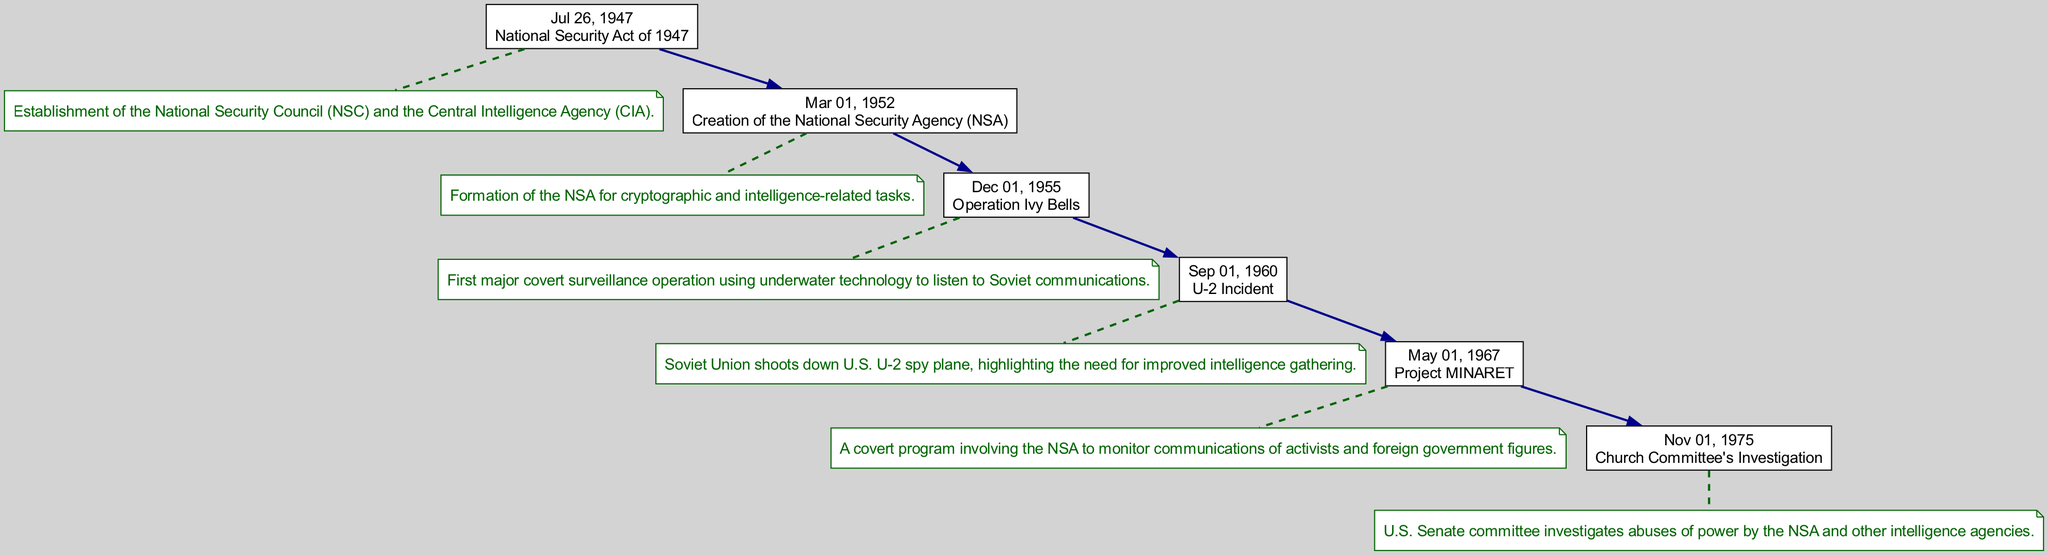What event established the NSA? The diagram shows the creation of the NSA on March 1, 1952, which is explicitly labeled as the formation of the NSA for cryptographic and intelligence-related tasks.
Answer: Creation of the National Security Agency (NSA) What was the first surveillance operation mentioned? According to the diagram, the first major covert surveillance operation noted is "Operation Ivy Bells," which took place in December 1955.
Answer: Operation Ivy Bells How many major events are listed in the timeline? Counting the events displayed in the diagram reveals there are six significant events indicating the establishment and evolution of the NSA and its programs.
Answer: 6 What program involved the monitoring of activists? The diagram indicates that "Project MINARET," initiated in May 1967, was a covert program involving the NSA to monitor communications of activists.
Answer: Project MINARET What incident highlighted the need for better intelligence gathering? The U-2 incident, marked in the diagram as occurring in September 1960, shows that the Soviet Union shot down a U.S. spy plane, which highlighted the deficiencies in intelligence operations.
Answer: U-2 Incident Which event prompted a Senate investigation into the NSA? The diagram indicates that the Church Committee's investigation in November 1975 was sparked by concerns over abuses of power by the NSA and other intelligence agencies.
Answer: Church Committee's Investigation What type of technology was used in Operation Ivy Bells? The description connected to "Operation Ivy Bells" in the diagram indicates that underwater technology was used for surveillance, specifically to listen to Soviet communications.
Answer: Underwater technology What is the relationship between the National Security Act and the NSA? The diagram shows that the establishment of the NSA follows the National Security Act of 1947, which laid the groundwork for intelligence organizations, including the NSA.
Answer: Established under the National Security Act Which event occurred directly before the creation of the NSA? Looking at the timeline, the event that came right before the creation of the NSA is the National Security Act of 1947, marked on July 26.
Answer: National Security Act of 1947 What was the purpose of the NSA when it was created? The diagram's description for the creation of the NSA notes its purpose as handling cryptographic and intelligence-related tasks, indicating its key functions from the outset.
Answer: Cryptographic and intelligence-related tasks 